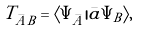Convert formula to latex. <formula><loc_0><loc_0><loc_500><loc_500>T _ { \bar { A } B } = \langle \Psi _ { \bar { A } } | \bar { a } \Psi _ { B } \rangle ,</formula> 